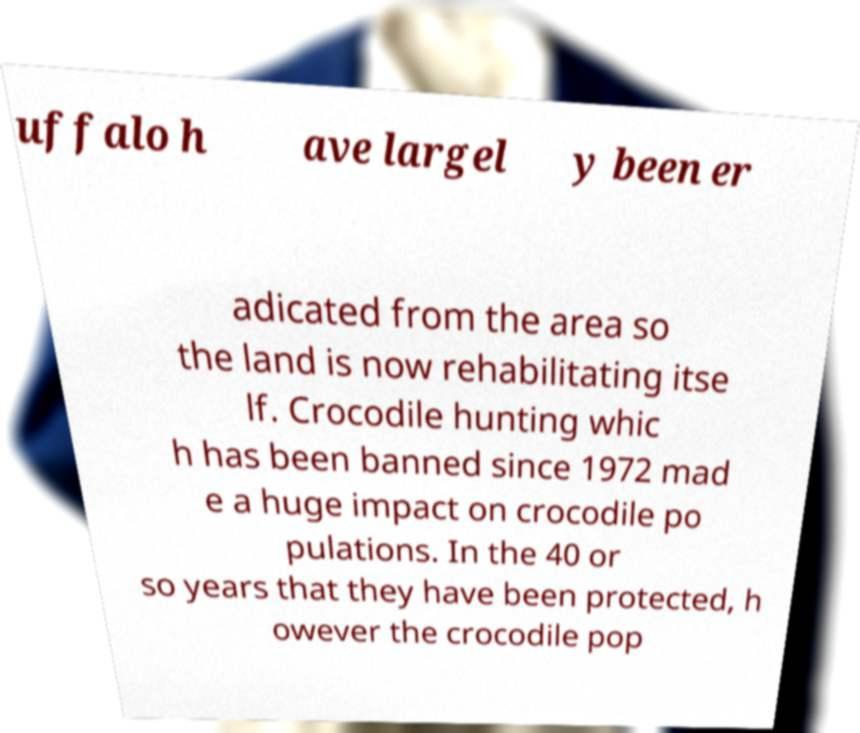Please identify and transcribe the text found in this image. uffalo h ave largel y been er adicated from the area so the land is now rehabilitating itse lf. Crocodile hunting whic h has been banned since 1972 mad e a huge impact on crocodile po pulations. In the 40 or so years that they have been protected, h owever the crocodile pop 